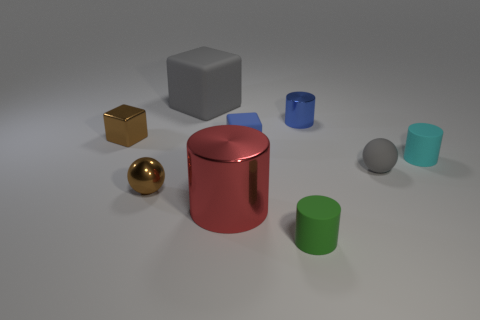There is a blue thing that is the same shape as the big red object; what size is it?
Provide a succinct answer. Small. Is the color of the small metallic sphere the same as the large rubber object?
Offer a very short reply. No. There is a metallic object that is left of the big red thing and behind the blue matte thing; what color is it?
Ensure brevity in your answer.  Brown. How many things are either small blue objects that are behind the brown block or brown metallic things?
Your answer should be very brief. 3. What is the color of the other big shiny object that is the same shape as the green thing?
Give a very brief answer. Red. Do the red thing and the gray thing in front of the small cyan rubber cylinder have the same shape?
Make the answer very short. No. What number of things are gray rubber things in front of the tiny shiny cylinder or rubber objects in front of the big red metal cylinder?
Offer a very short reply. 2. Are there fewer rubber cylinders that are on the right side of the cyan object than big blocks?
Offer a terse response. Yes. Does the big red object have the same material as the small object that is to the right of the small gray matte object?
Provide a succinct answer. No. What is the red cylinder made of?
Ensure brevity in your answer.  Metal. 